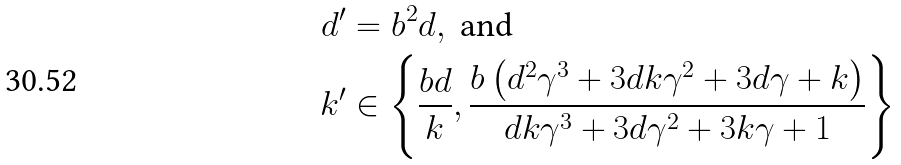Convert formula to latex. <formula><loc_0><loc_0><loc_500><loc_500>d ^ { \prime } & = b ^ { 2 } d , \text { and } \\ k ^ { \prime } & \in \left \{ \frac { b d } { k } , \frac { b \left ( d ^ { 2 } \gamma ^ { 3 } + 3 d k \gamma ^ { 2 } + 3 d \gamma + k \right ) } { d k \gamma ^ { 3 } + 3 d \gamma ^ { 2 } + 3 k \gamma + 1 } \right \}</formula> 